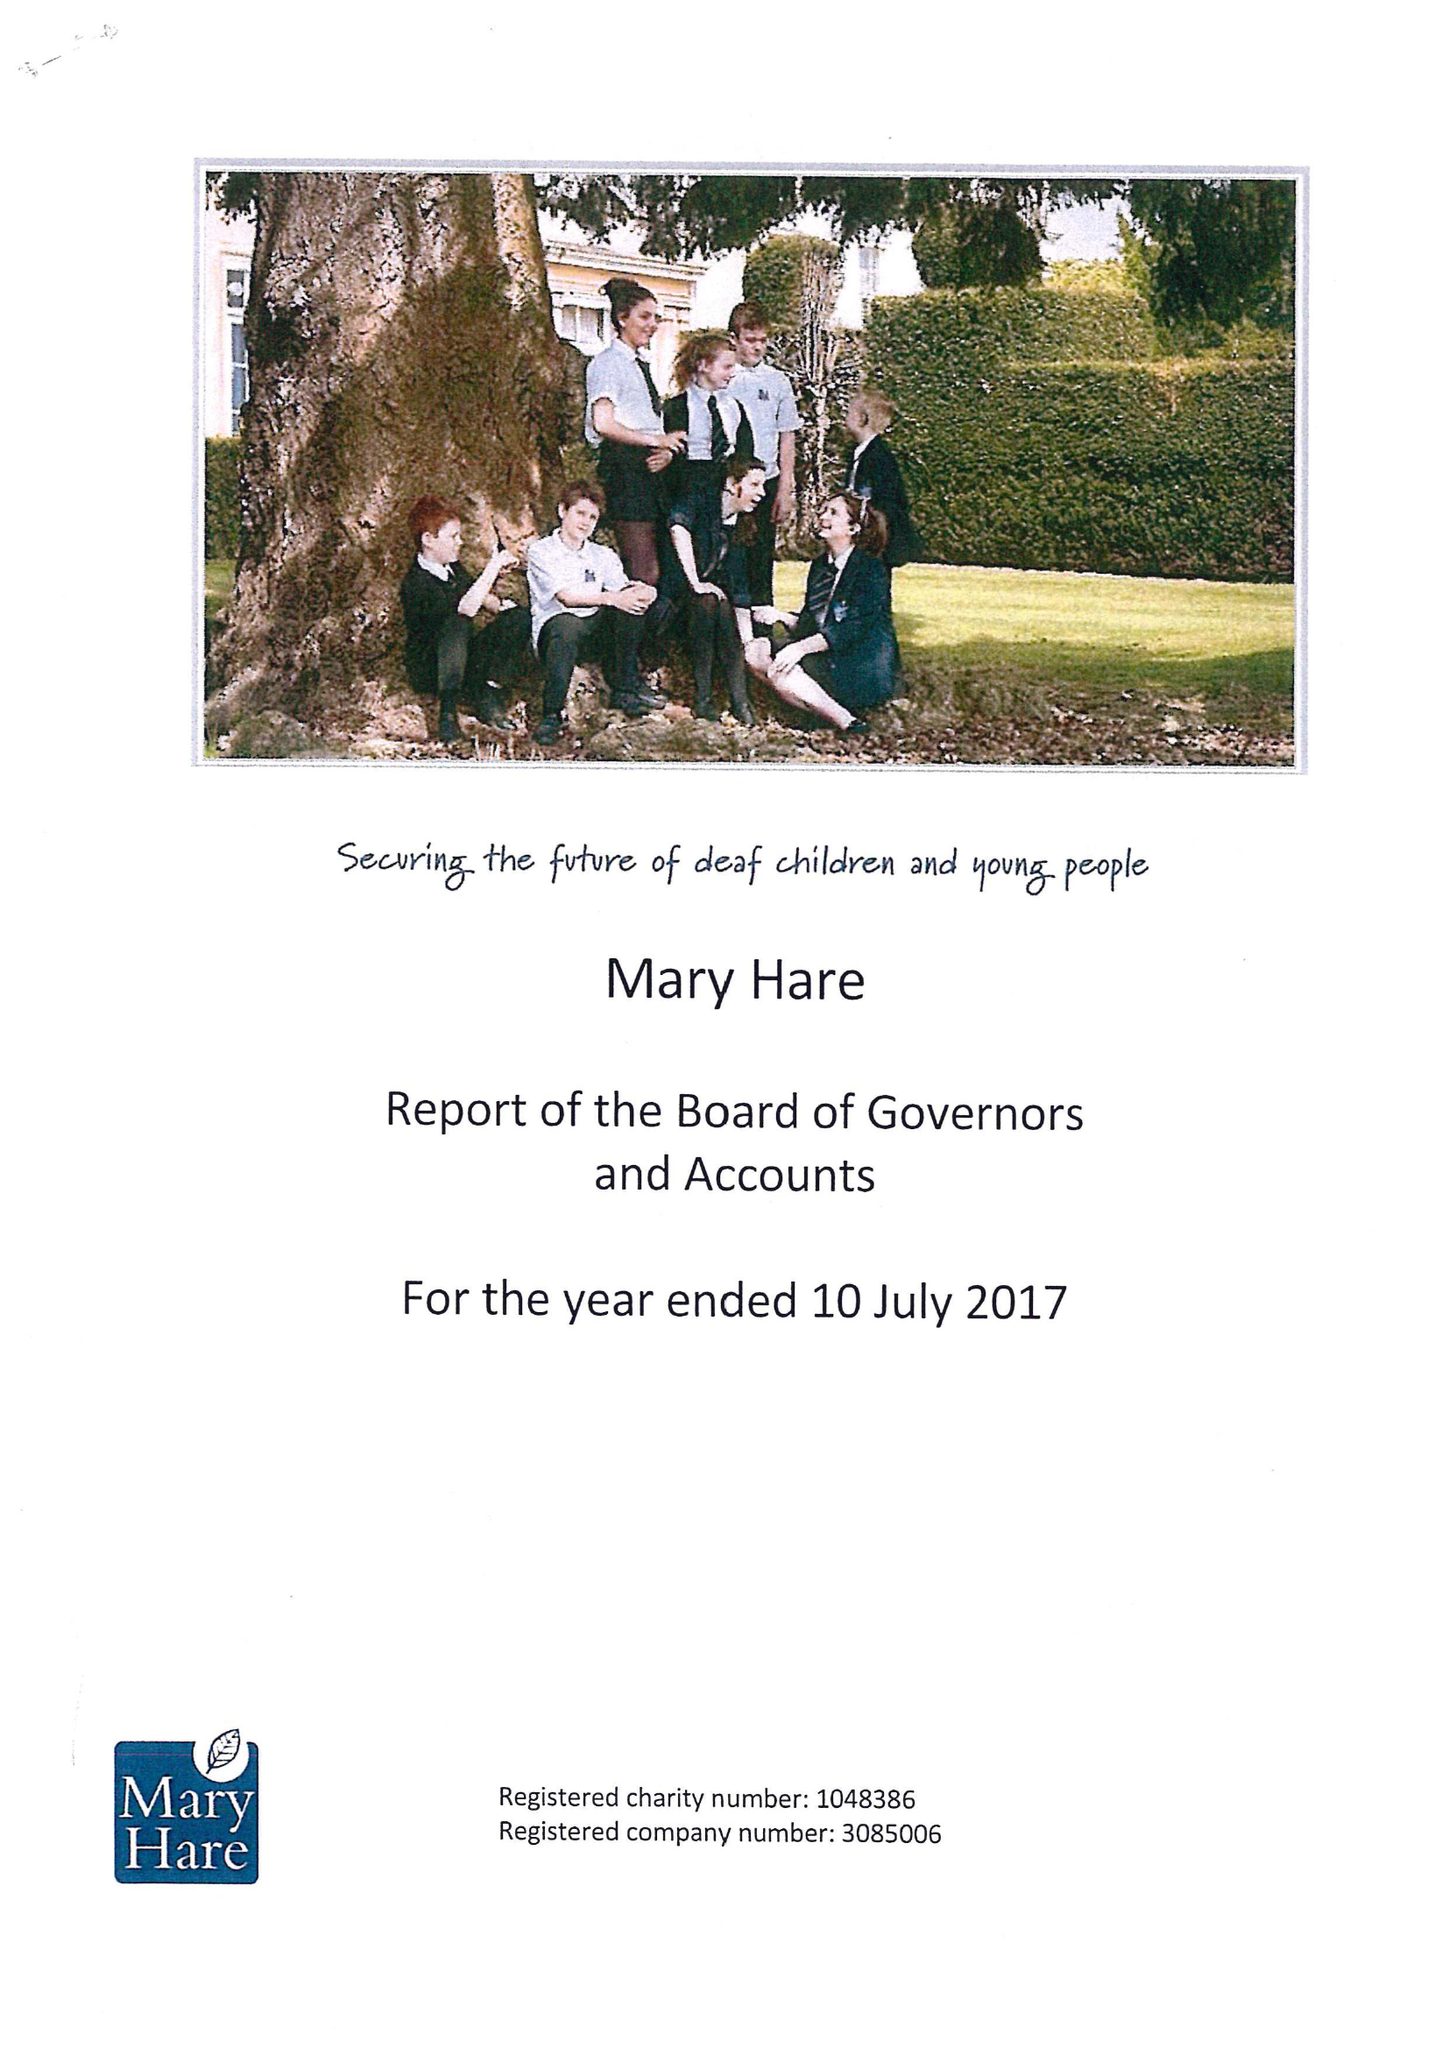What is the value for the address__postcode?
Answer the question using a single word or phrase. RG14 3BQ 